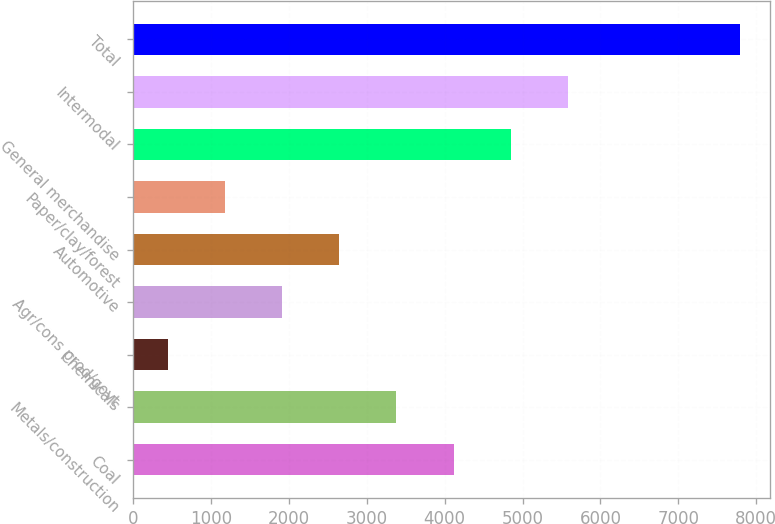Convert chart. <chart><loc_0><loc_0><loc_500><loc_500><bar_chart><fcel>Coal<fcel>Metals/construction<fcel>Chemicals<fcel>Agr/cons prod/govt<fcel>Automotive<fcel>Paper/clay/forest<fcel>General merchandise<fcel>Intermodal<fcel>Total<nl><fcel>4114.3<fcel>3379.86<fcel>442.1<fcel>1910.98<fcel>2645.42<fcel>1176.54<fcel>4848.74<fcel>5583.18<fcel>7786.5<nl></chart> 